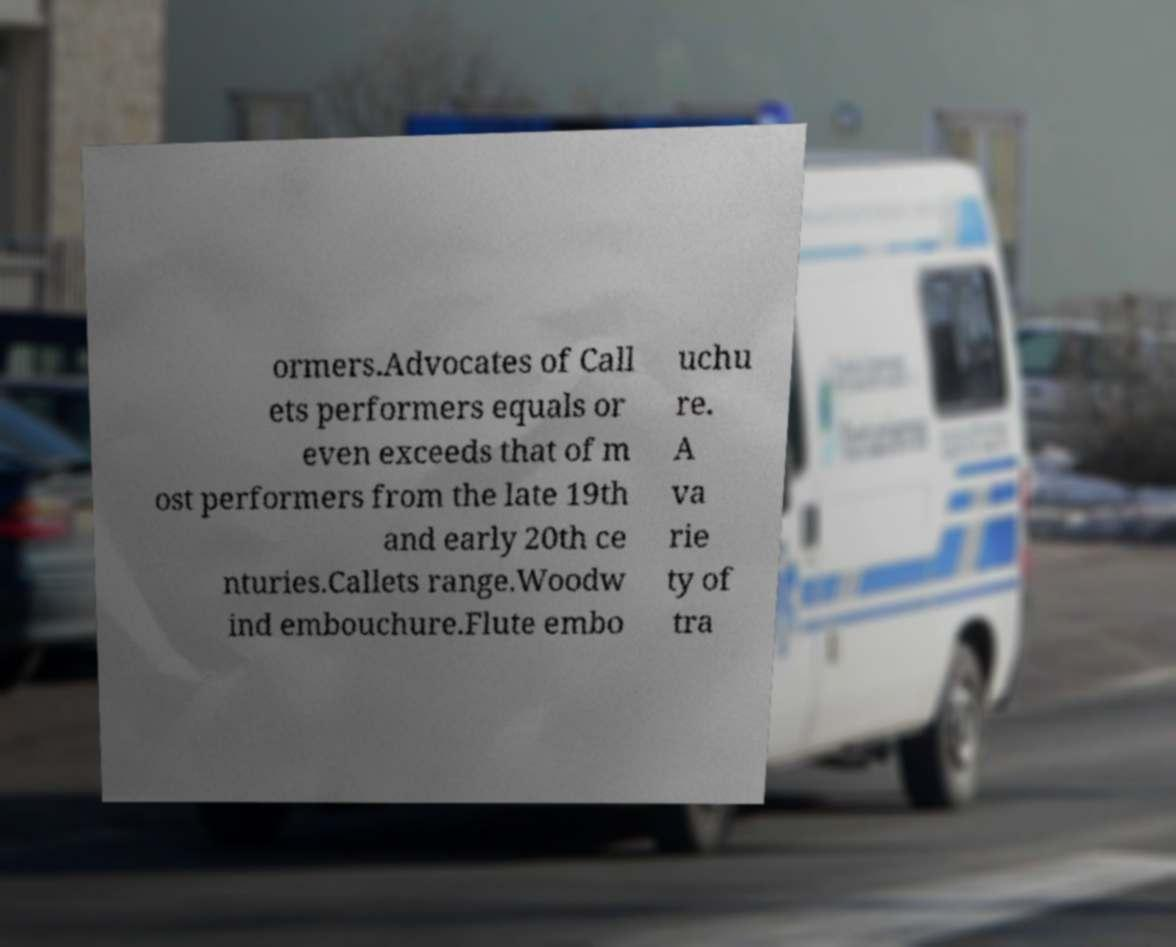Please read and relay the text visible in this image. What does it say? ormers.Advocates of Call ets performers equals or even exceeds that of m ost performers from the late 19th and early 20th ce nturies.Callets range.Woodw ind embouchure.Flute embo uchu re. A va rie ty of tra 